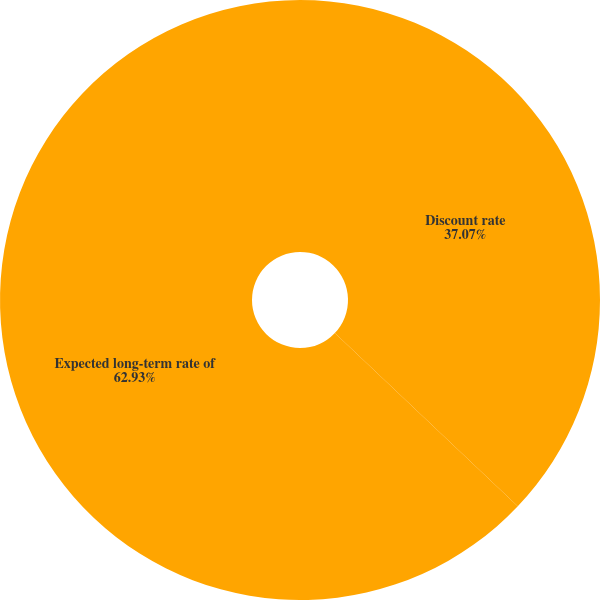Convert chart. <chart><loc_0><loc_0><loc_500><loc_500><pie_chart><fcel>Discount rate<fcel>Expected long-term rate of<nl><fcel>37.07%<fcel>62.93%<nl></chart> 